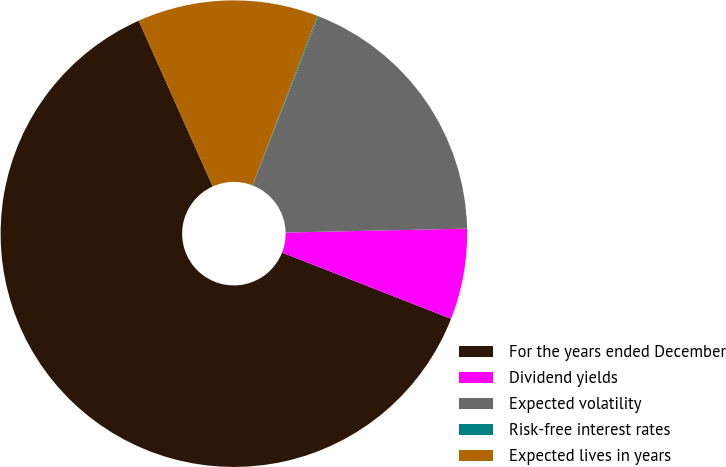Convert chart to OTSL. <chart><loc_0><loc_0><loc_500><loc_500><pie_chart><fcel>For the years ended December<fcel>Dividend yields<fcel>Expected volatility<fcel>Risk-free interest rates<fcel>Expected lives in years<nl><fcel>62.36%<fcel>6.29%<fcel>18.75%<fcel>0.07%<fcel>12.52%<nl></chart> 